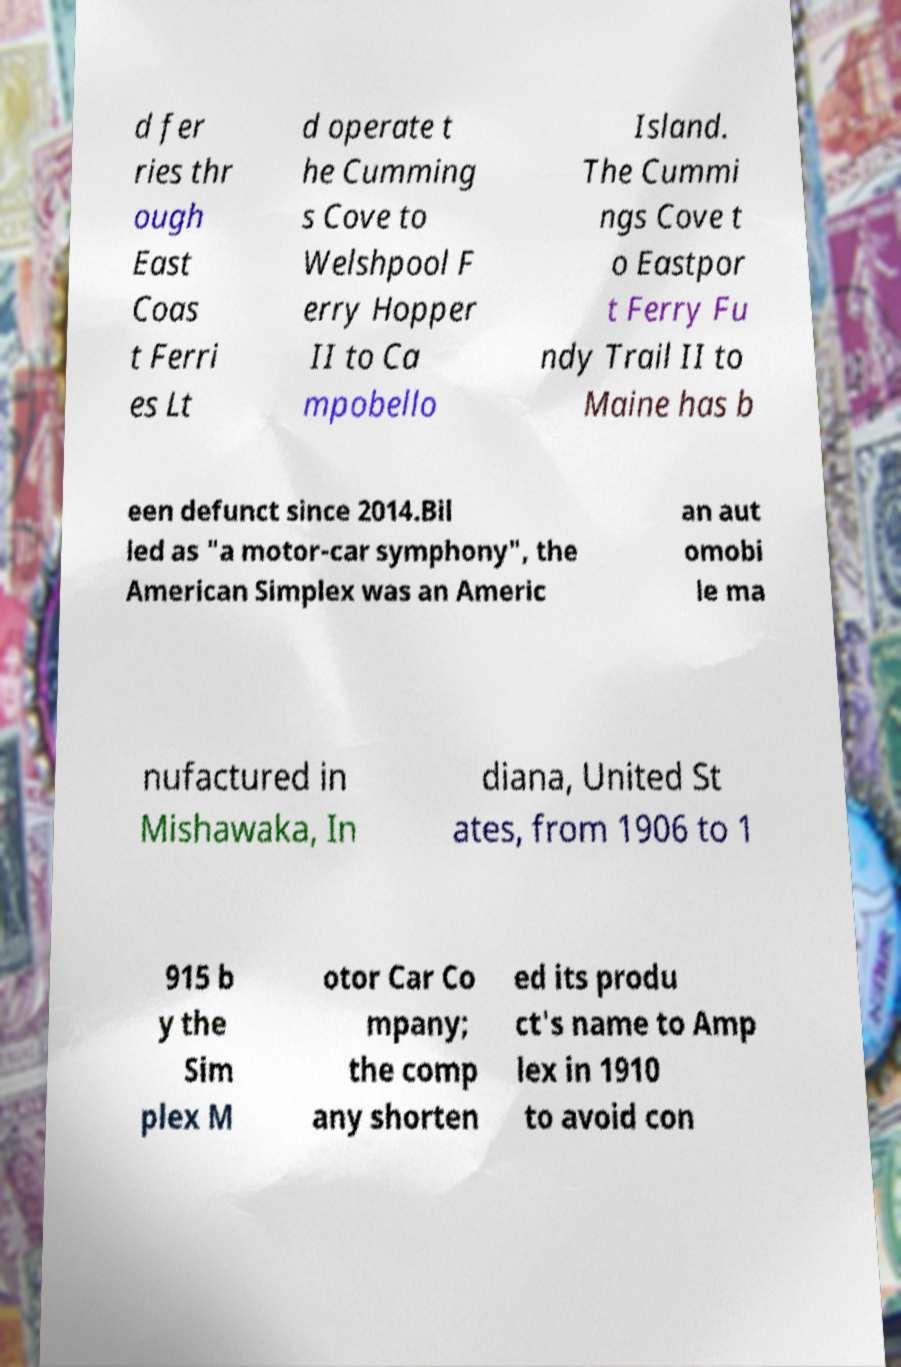Can you read and provide the text displayed in the image?This photo seems to have some interesting text. Can you extract and type it out for me? d fer ries thr ough East Coas t Ferri es Lt d operate t he Cumming s Cove to Welshpool F erry Hopper II to Ca mpobello Island. The Cummi ngs Cove t o Eastpor t Ferry Fu ndy Trail II to Maine has b een defunct since 2014.Bil led as "a motor-car symphony", the American Simplex was an Americ an aut omobi le ma nufactured in Mishawaka, In diana, United St ates, from 1906 to 1 915 b y the Sim plex M otor Car Co mpany; the comp any shorten ed its produ ct's name to Amp lex in 1910 to avoid con 